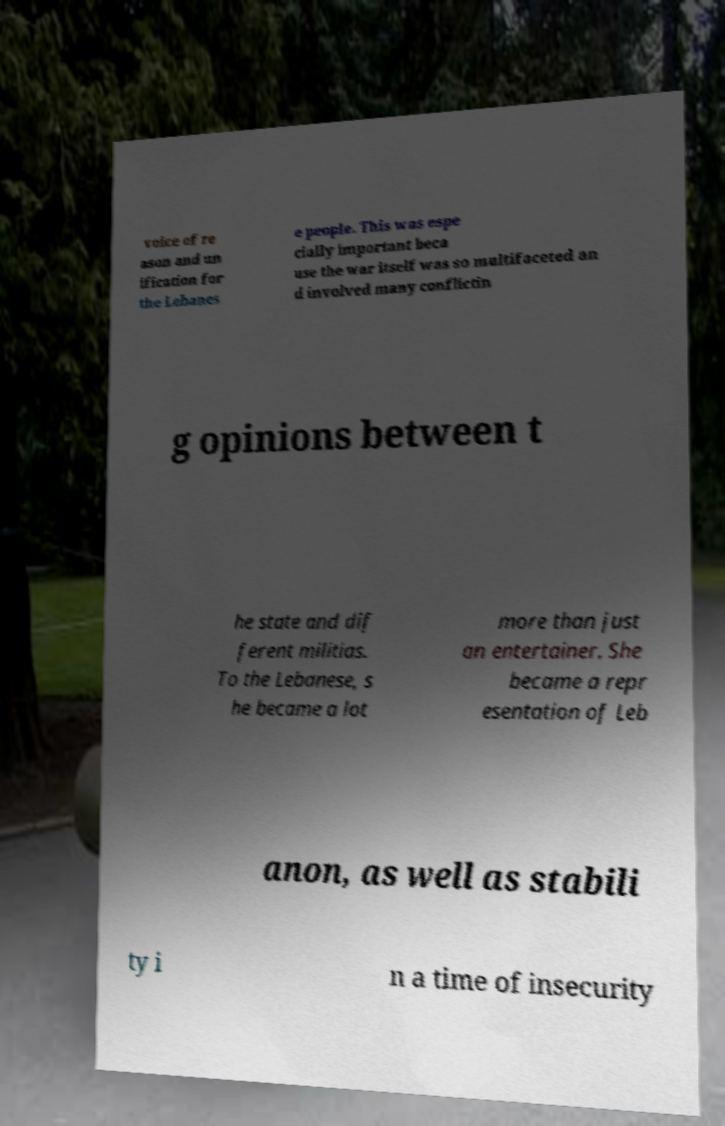Could you extract and type out the text from this image? voice of re ason and un ification for the Lebanes e people. This was espe cially important beca use the war itself was so multifaceted an d involved many conflictin g opinions between t he state and dif ferent militias. To the Lebanese, s he became a lot more than just an entertainer. She became a repr esentation of Leb anon, as well as stabili ty i n a time of insecurity 